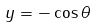<formula> <loc_0><loc_0><loc_500><loc_500>y = - \cos \theta</formula> 